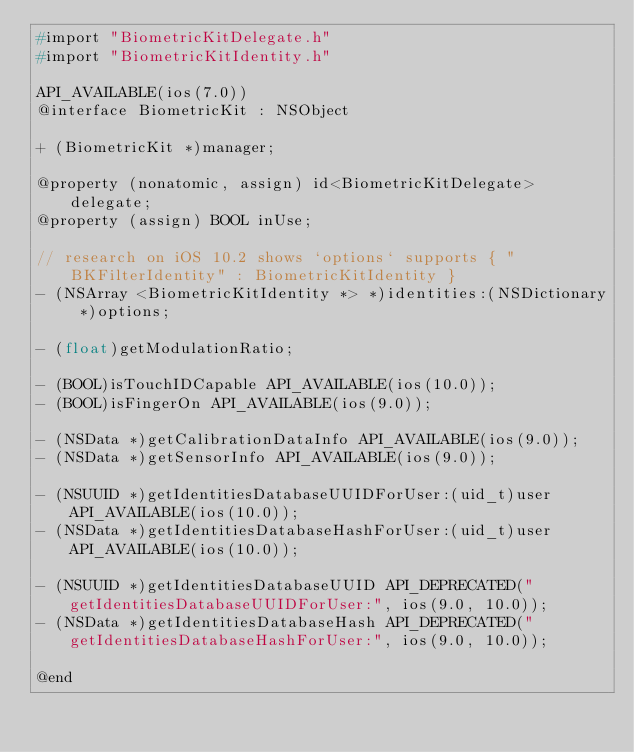<code> <loc_0><loc_0><loc_500><loc_500><_C_>#import "BiometricKitDelegate.h"
#import "BiometricKitIdentity.h"

API_AVAILABLE(ios(7.0))
@interface BiometricKit : NSObject

+ (BiometricKit *)manager;

@property (nonatomic, assign) id<BiometricKitDelegate> delegate;
@property (assign) BOOL inUse;

// research on iOS 10.2 shows `options` supports { "BKFilterIdentity" : BiometricKitIdentity }
- (NSArray <BiometricKitIdentity *> *)identities:(NSDictionary *)options;

- (float)getModulationRatio;

- (BOOL)isTouchIDCapable API_AVAILABLE(ios(10.0));
- (BOOL)isFingerOn API_AVAILABLE(ios(9.0));

- (NSData *)getCalibrationDataInfo API_AVAILABLE(ios(9.0));
- (NSData *)getSensorInfo API_AVAILABLE(ios(9.0));

- (NSUUID *)getIdentitiesDatabaseUUIDForUser:(uid_t)user API_AVAILABLE(ios(10.0));
- (NSData *)getIdentitiesDatabaseHashForUser:(uid_t)user API_AVAILABLE(ios(10.0));

- (NSUUID *)getIdentitiesDatabaseUUID API_DEPRECATED("getIdentitiesDatabaseUUIDForUser:", ios(9.0, 10.0));
- (NSData *)getIdentitiesDatabaseHash API_DEPRECATED("getIdentitiesDatabaseHashForUser:", ios(9.0, 10.0));

@end
</code> 